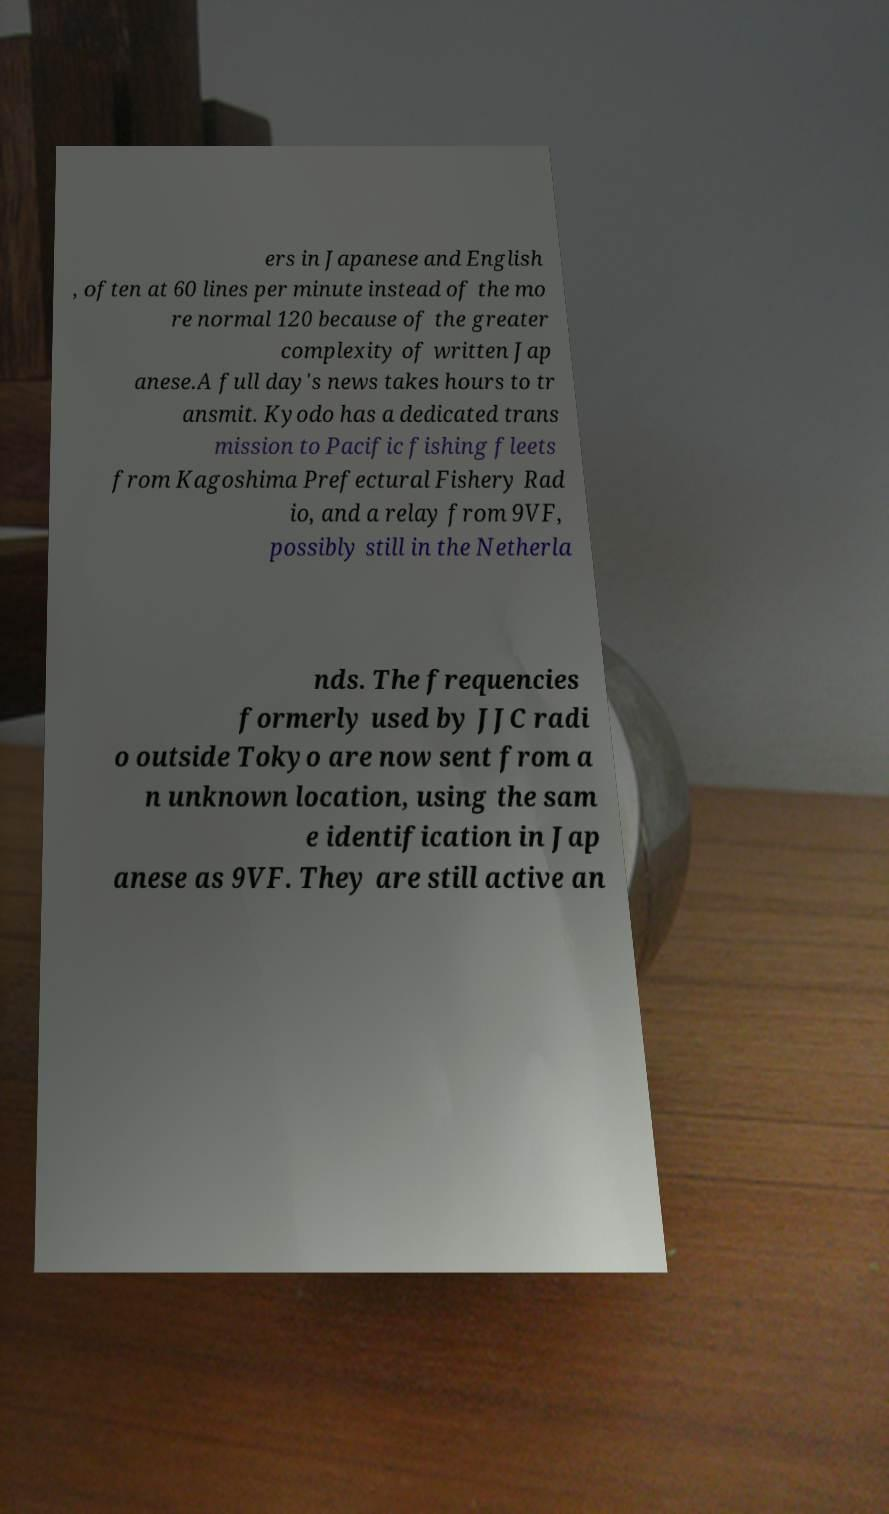Can you accurately transcribe the text from the provided image for me? ers in Japanese and English , often at 60 lines per minute instead of the mo re normal 120 because of the greater complexity of written Jap anese.A full day's news takes hours to tr ansmit. Kyodo has a dedicated trans mission to Pacific fishing fleets from Kagoshima Prefectural Fishery Rad io, and a relay from 9VF, possibly still in the Netherla nds. The frequencies formerly used by JJC radi o outside Tokyo are now sent from a n unknown location, using the sam e identification in Jap anese as 9VF. They are still active an 